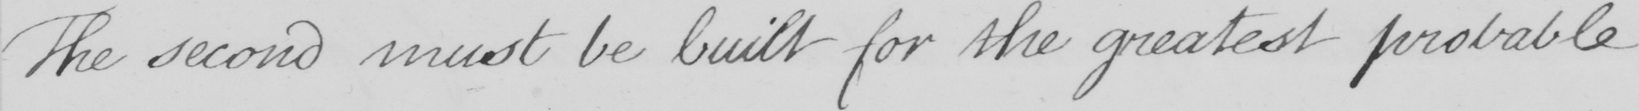What is written in this line of handwriting? The second must be built for the greatest probable 